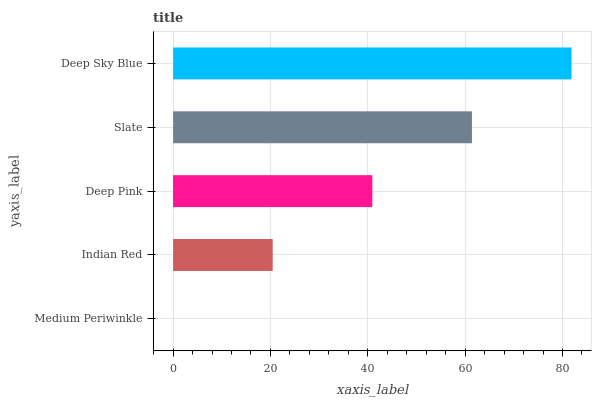Is Medium Periwinkle the minimum?
Answer yes or no. Yes. Is Deep Sky Blue the maximum?
Answer yes or no. Yes. Is Indian Red the minimum?
Answer yes or no. No. Is Indian Red the maximum?
Answer yes or no. No. Is Indian Red greater than Medium Periwinkle?
Answer yes or no. Yes. Is Medium Periwinkle less than Indian Red?
Answer yes or no. Yes. Is Medium Periwinkle greater than Indian Red?
Answer yes or no. No. Is Indian Red less than Medium Periwinkle?
Answer yes or no. No. Is Deep Pink the high median?
Answer yes or no. Yes. Is Deep Pink the low median?
Answer yes or no. Yes. Is Indian Red the high median?
Answer yes or no. No. Is Deep Sky Blue the low median?
Answer yes or no. No. 